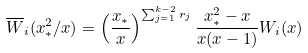Convert formula to latex. <formula><loc_0><loc_0><loc_500><loc_500>\overline { W } _ { i } ( x _ { \ast } ^ { 2 } / x ) = \left ( \frac { x _ { \ast } } { x } \right ) ^ { \sum _ { j = 1 } ^ { k - 2 } r _ { j } } \frac { x _ { \ast } ^ { 2 } - x } { x ( x - 1 ) } W _ { i } ( x )</formula> 